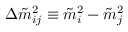<formula> <loc_0><loc_0><loc_500><loc_500>\Delta \tilde { m } _ { i j } ^ { 2 } \equiv \tilde { m } _ { i } ^ { 2 } - \tilde { m } _ { j } ^ { 2 }</formula> 